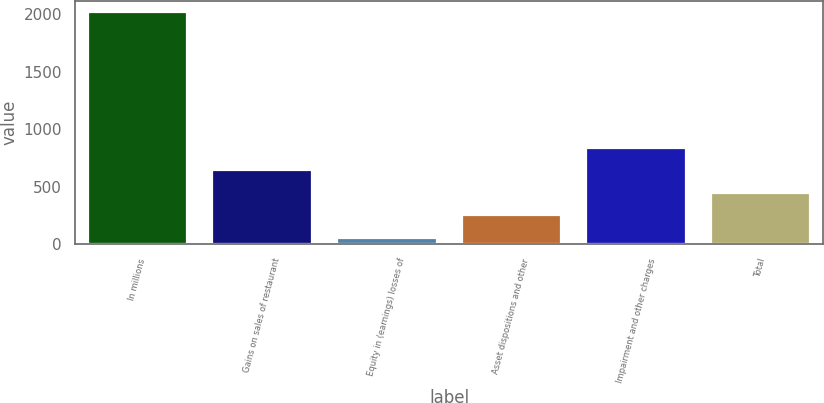Convert chart to OTSL. <chart><loc_0><loc_0><loc_500><loc_500><bar_chart><fcel>In millions<fcel>Gains on sales of restaurant<fcel>Equity in (earnings) losses of<fcel>Asset dispositions and other<fcel>Impairment and other charges<fcel>Total<nl><fcel>2016<fcel>643.16<fcel>54.8<fcel>250.92<fcel>839.28<fcel>447.04<nl></chart> 